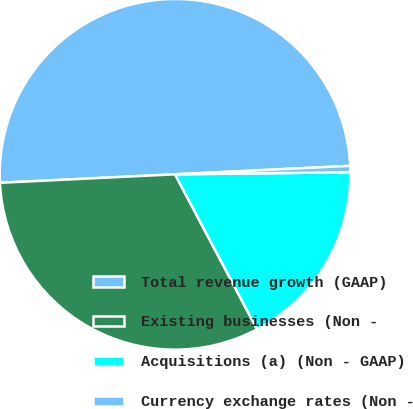<chart> <loc_0><loc_0><loc_500><loc_500><pie_chart><fcel>Total revenue growth (GAAP)<fcel>Existing businesses (Non -<fcel>Acquisitions (a) (Non - GAAP)<fcel>Currency exchange rates (Non -<nl><fcel>50.0%<fcel>31.98%<fcel>17.44%<fcel>0.58%<nl></chart> 